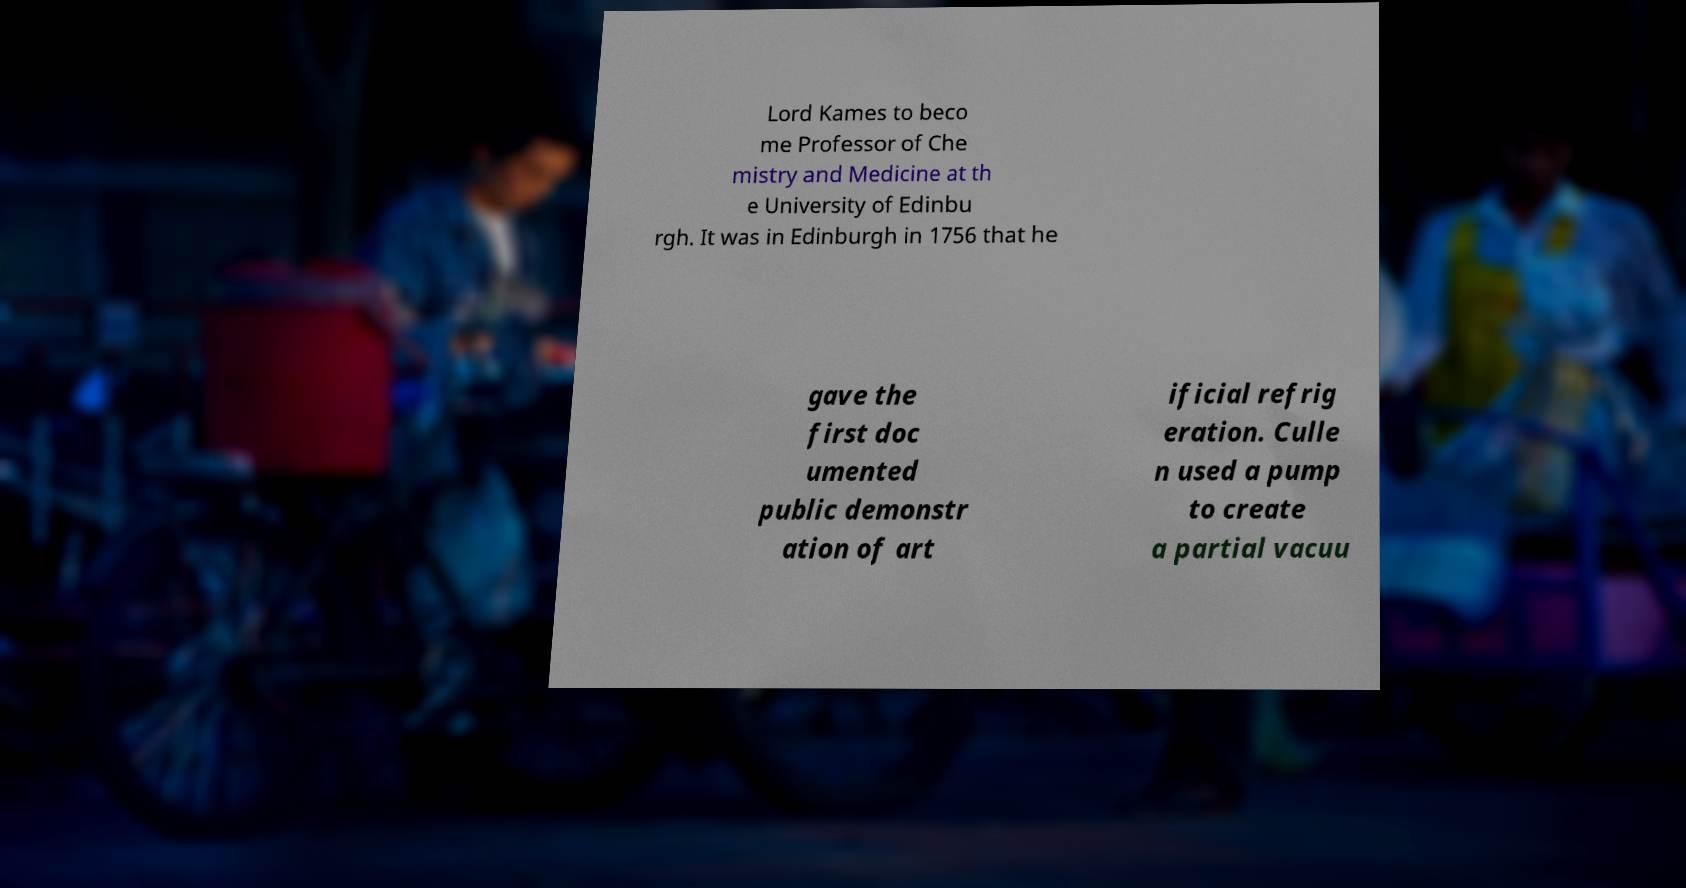Could you extract and type out the text from this image? Lord Kames to beco me Professor of Che mistry and Medicine at th e University of Edinbu rgh. It was in Edinburgh in 1756 that he gave the first doc umented public demonstr ation of art ificial refrig eration. Culle n used a pump to create a partial vacuu 